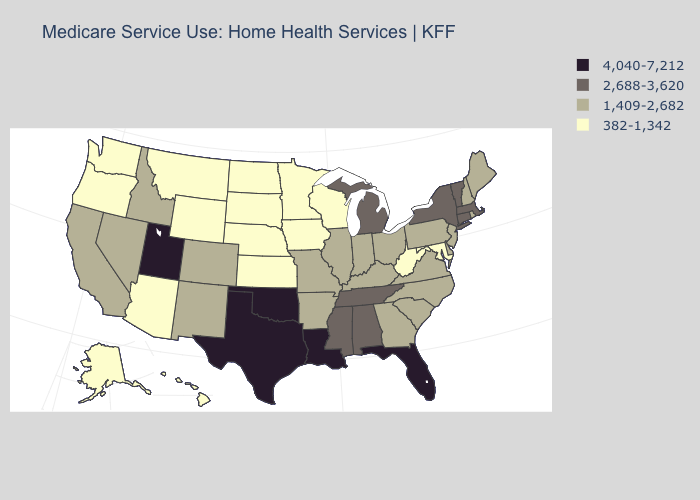What is the highest value in the West ?
Be succinct. 4,040-7,212. What is the value of New Mexico?
Write a very short answer. 1,409-2,682. Name the states that have a value in the range 4,040-7,212?
Write a very short answer. Florida, Louisiana, Oklahoma, Texas, Utah. Among the states that border Indiana , which have the lowest value?
Answer briefly. Illinois, Kentucky, Ohio. Name the states that have a value in the range 4,040-7,212?
Keep it brief. Florida, Louisiana, Oklahoma, Texas, Utah. What is the value of Idaho?
Give a very brief answer. 1,409-2,682. Name the states that have a value in the range 4,040-7,212?
Short answer required. Florida, Louisiana, Oklahoma, Texas, Utah. What is the lowest value in the MidWest?
Write a very short answer. 382-1,342. What is the highest value in states that border California?
Answer briefly. 1,409-2,682. Does Tennessee have a higher value than Utah?
Give a very brief answer. No. Among the states that border Michigan , does Wisconsin have the lowest value?
Write a very short answer. Yes. What is the lowest value in states that border Nevada?
Be succinct. 382-1,342. What is the highest value in states that border Arkansas?
Answer briefly. 4,040-7,212. Is the legend a continuous bar?
Give a very brief answer. No. Which states have the lowest value in the USA?
Quick response, please. Alaska, Arizona, Hawaii, Iowa, Kansas, Maryland, Minnesota, Montana, Nebraska, North Dakota, Oregon, South Dakota, Washington, West Virginia, Wisconsin, Wyoming. 